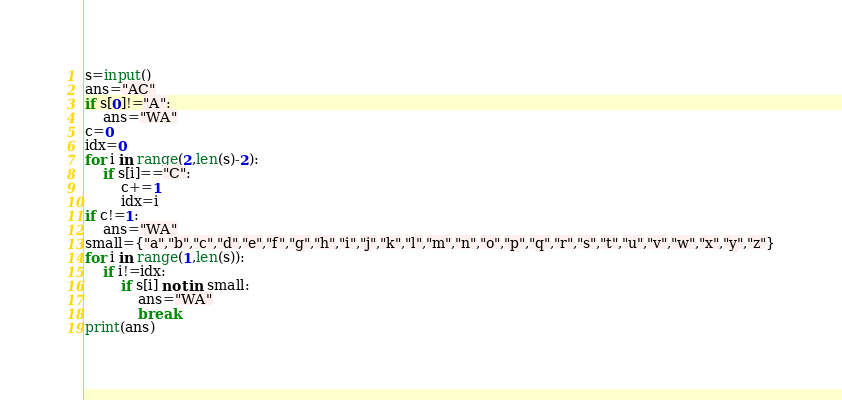Convert code to text. <code><loc_0><loc_0><loc_500><loc_500><_Python_>s=input()
ans="AC"
if s[0]!="A":
    ans="WA"
c=0
idx=0
for i in range(2,len(s)-2):
    if s[i]=="C":
        c+=1
        idx=i
if c!=1:
    ans="WA"
small={"a","b","c","d","e","f","g","h","i","j","k","l","m","n","o","p","q","r","s","t","u","v","w","x","y","z"}
for i in range(1,len(s)):
    if i!=idx:
        if s[i] not in small:
            ans="WA"
            break
print(ans)
</code> 